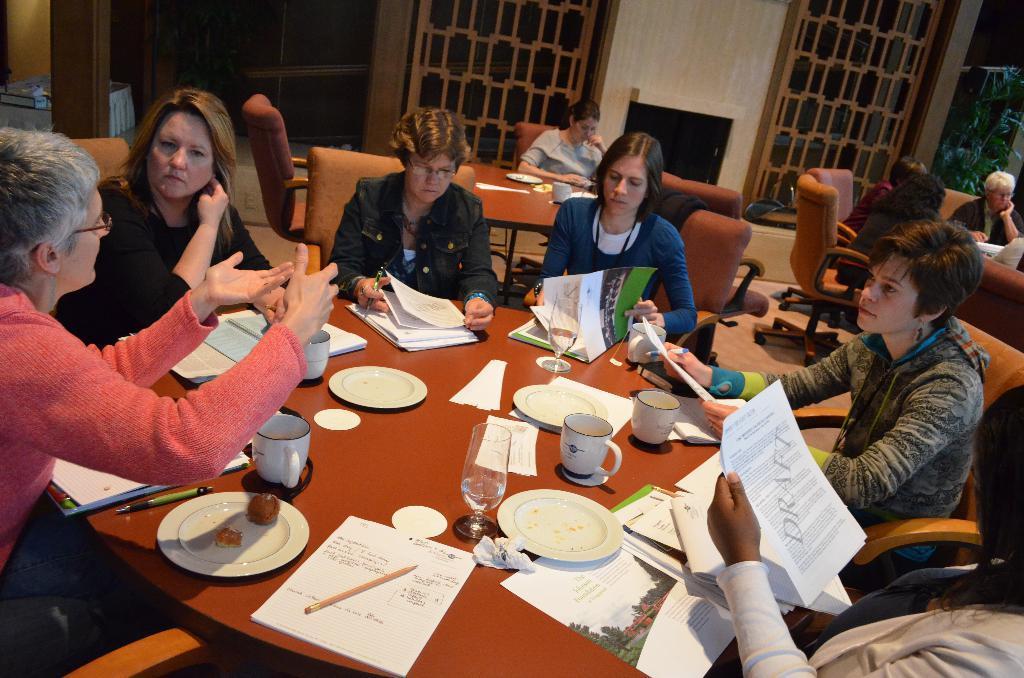Describe this image in one or two sentences. There is a group of people. They are sitting on a chairs. There is a table. There is a plate,pen,glass,cup,saucer and food item on a table. We can see in background windows,trees. 